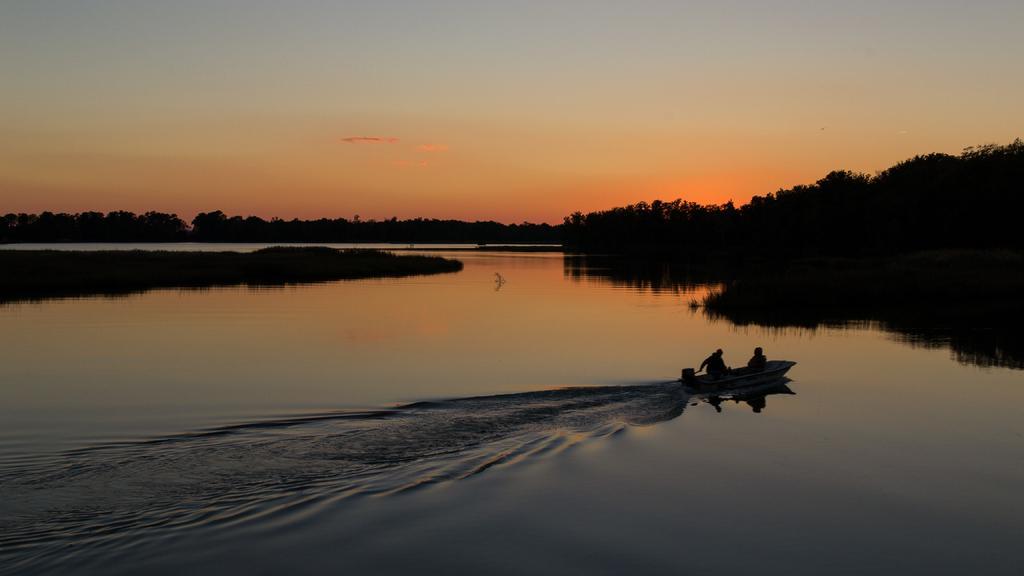Please provide a concise description of this image. In this picture we can see water at the bottom, on the right side there is a boat, in the background we can see trees, there is the sky at the top of the picture. 